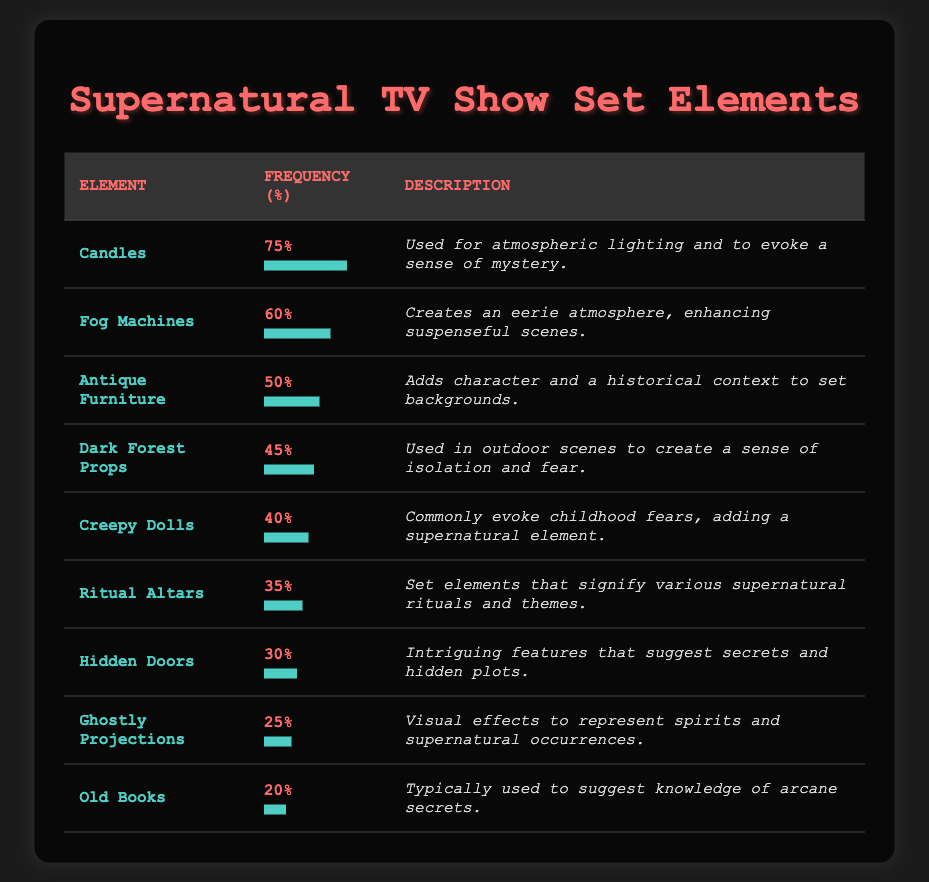What is the most frequently used set element in supernatural TV shows? The table lists "Candles" with a frequency of 75%, which is higher than any other element.
Answer: Candles Which set element is used more frequently: Fog Machines or Antique Furniture? Fog Machines have a frequency of 60%, while Antique Furniture has a frequency of 50%. Therefore, Fog Machines are used more frequently.
Answer: Fog Machines What is the combined frequency of Creepy Dolls and Ritual Altars? Creepy Dolls have a frequency of 40% and Ritual Altars have a frequency of 35%. The total frequency is 40% + 35% = 75%.
Answer: 75% Is the frequency of Ghostly Projections greater than that of Hidden Doors? Ghostly Projections have a frequency of 25%, while Hidden Doors have a frequency of 30%. Since 25% < 30%, the statement is false.
Answer: No What is the average frequency of the top three most used set elements? The top three set elements are Candles (75%), Fog Machines (60%), and Antique Furniture (50%). Their total frequency is 75 + 60 + 50 = 185, and dividing by 3 gives an average of 185/3 ≈ 61.67%.
Answer: Approximately 61.67% How many set elements have a frequency lower than 30%? The table shows Ghostly Projections at 25% and Old Books at 20%. Thus, there are two set elements with a frequency lower than 30%.
Answer: 2 Which set element has the lowest frequency? Reviewing the table, Old Books have the lowest frequency at 20%, confirming they are the least used element.
Answer: Old Books Is the use of Dark Forest Props significantly higher than that of Ghostly Projections? Dark Forest Props have a frequency of 45%, while Ghostly Projections have a frequency of 25%. The difference is 45% - 25% = 20%, which indicates that Dark Forest Props are used significantly more.
Answer: Yes 